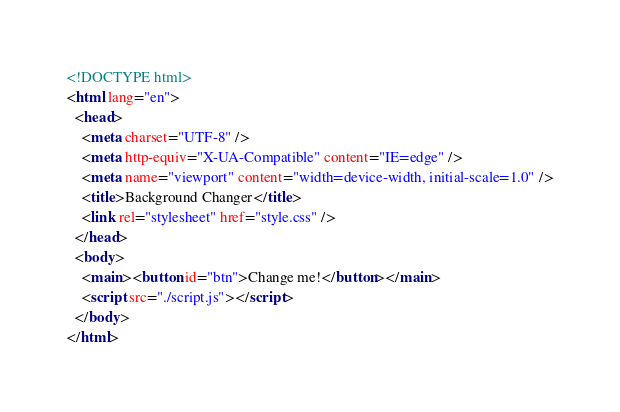<code> <loc_0><loc_0><loc_500><loc_500><_HTML_><!DOCTYPE html>
<html lang="en">
  <head>
    <meta charset="UTF-8" />
    <meta http-equiv="X-UA-Compatible" content="IE=edge" />
    <meta name="viewport" content="width=device-width, initial-scale=1.0" />
    <title>Background Changer</title>
    <link rel="stylesheet" href="style.css" />
  </head>
  <body>
    <main><button id="btn">Change me!</button></main>
    <script src="./script.js"></script>
  </body>
</html>
</code> 